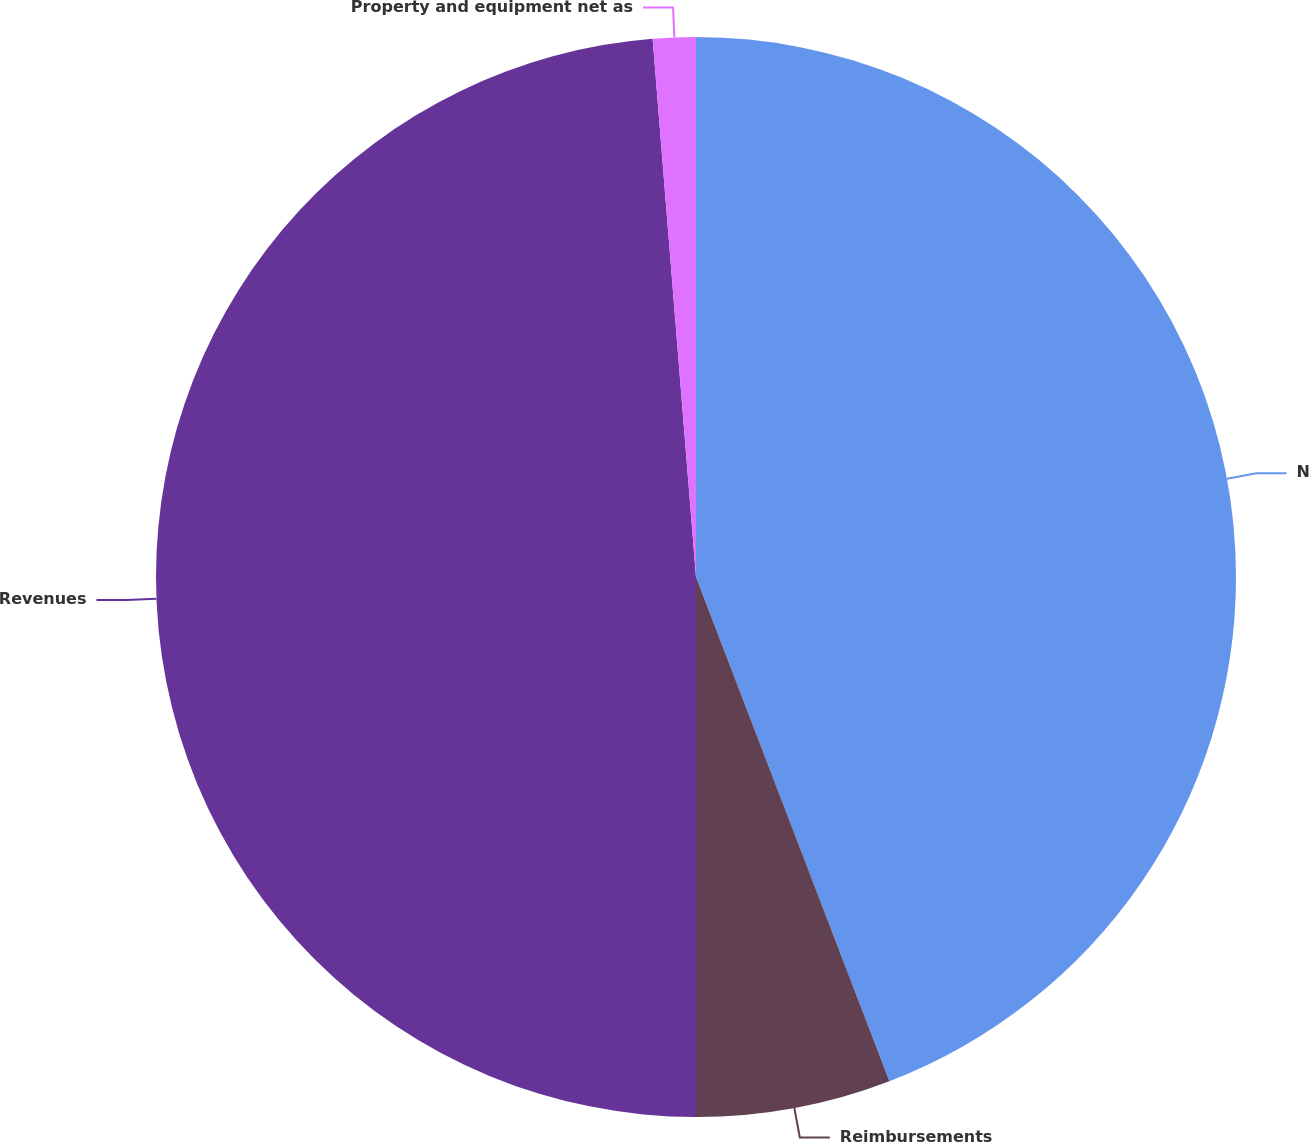Convert chart. <chart><loc_0><loc_0><loc_500><loc_500><pie_chart><fcel>Net revenues<fcel>Reimbursements<fcel>Revenues<fcel>Property and equipment net as<nl><fcel>44.17%<fcel>5.83%<fcel>48.72%<fcel>1.28%<nl></chart> 